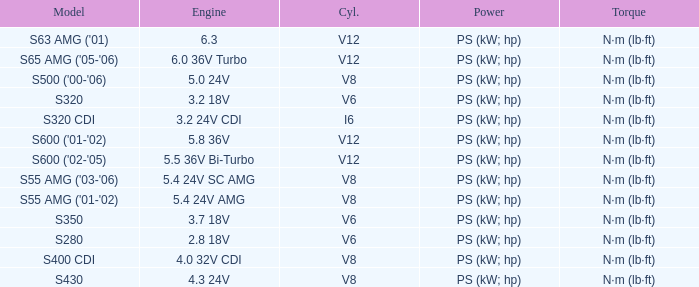Which engine features a model of s320 cdi? 3.2 24V CDI. 